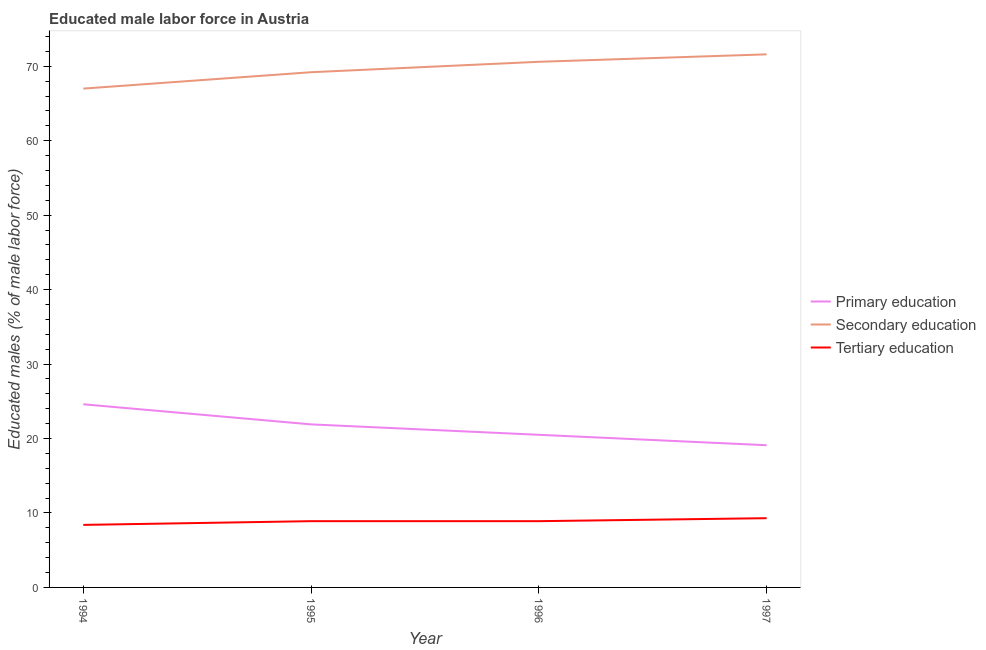How many different coloured lines are there?
Your response must be concise. 3. Does the line corresponding to percentage of male labor force who received tertiary education intersect with the line corresponding to percentage of male labor force who received primary education?
Your answer should be very brief. No. What is the percentage of male labor force who received secondary education in 1996?
Offer a very short reply. 70.6. Across all years, what is the maximum percentage of male labor force who received primary education?
Make the answer very short. 24.6. Across all years, what is the minimum percentage of male labor force who received primary education?
Your answer should be compact. 19.1. In which year was the percentage of male labor force who received secondary education maximum?
Ensure brevity in your answer.  1997. In which year was the percentage of male labor force who received primary education minimum?
Keep it short and to the point. 1997. What is the total percentage of male labor force who received secondary education in the graph?
Your answer should be very brief. 278.4. What is the difference between the percentage of male labor force who received primary education in 1994 and that in 1996?
Keep it short and to the point. 4.1. What is the difference between the percentage of male labor force who received secondary education in 1995 and the percentage of male labor force who received primary education in 1996?
Your response must be concise. 48.7. What is the average percentage of male labor force who received secondary education per year?
Ensure brevity in your answer.  69.6. In the year 1995, what is the difference between the percentage of male labor force who received primary education and percentage of male labor force who received secondary education?
Your response must be concise. -47.3. What is the ratio of the percentage of male labor force who received tertiary education in 1994 to that in 1996?
Offer a very short reply. 0.94. What is the difference between the highest and the lowest percentage of male labor force who received tertiary education?
Offer a very short reply. 0.9. Is the sum of the percentage of male labor force who received secondary education in 1994 and 1997 greater than the maximum percentage of male labor force who received primary education across all years?
Keep it short and to the point. Yes. How many lines are there?
Offer a very short reply. 3. How many years are there in the graph?
Ensure brevity in your answer.  4. What is the difference between two consecutive major ticks on the Y-axis?
Your answer should be very brief. 10. Where does the legend appear in the graph?
Offer a very short reply. Center right. How many legend labels are there?
Make the answer very short. 3. How are the legend labels stacked?
Provide a short and direct response. Vertical. What is the title of the graph?
Your answer should be compact. Educated male labor force in Austria. Does "Transport" appear as one of the legend labels in the graph?
Keep it short and to the point. No. What is the label or title of the X-axis?
Give a very brief answer. Year. What is the label or title of the Y-axis?
Provide a short and direct response. Educated males (% of male labor force). What is the Educated males (% of male labor force) of Primary education in 1994?
Your answer should be compact. 24.6. What is the Educated males (% of male labor force) of Secondary education in 1994?
Give a very brief answer. 67. What is the Educated males (% of male labor force) of Tertiary education in 1994?
Make the answer very short. 8.4. What is the Educated males (% of male labor force) in Primary education in 1995?
Your answer should be compact. 21.9. What is the Educated males (% of male labor force) of Secondary education in 1995?
Ensure brevity in your answer.  69.2. What is the Educated males (% of male labor force) of Tertiary education in 1995?
Give a very brief answer. 8.9. What is the Educated males (% of male labor force) of Primary education in 1996?
Your response must be concise. 20.5. What is the Educated males (% of male labor force) of Secondary education in 1996?
Your answer should be very brief. 70.6. What is the Educated males (% of male labor force) in Tertiary education in 1996?
Your answer should be compact. 8.9. What is the Educated males (% of male labor force) in Primary education in 1997?
Ensure brevity in your answer.  19.1. What is the Educated males (% of male labor force) of Secondary education in 1997?
Ensure brevity in your answer.  71.6. What is the Educated males (% of male labor force) in Tertiary education in 1997?
Your answer should be compact. 9.3. Across all years, what is the maximum Educated males (% of male labor force) in Primary education?
Keep it short and to the point. 24.6. Across all years, what is the maximum Educated males (% of male labor force) of Secondary education?
Keep it short and to the point. 71.6. Across all years, what is the maximum Educated males (% of male labor force) in Tertiary education?
Ensure brevity in your answer.  9.3. Across all years, what is the minimum Educated males (% of male labor force) of Primary education?
Your response must be concise. 19.1. Across all years, what is the minimum Educated males (% of male labor force) in Secondary education?
Provide a short and direct response. 67. Across all years, what is the minimum Educated males (% of male labor force) of Tertiary education?
Offer a terse response. 8.4. What is the total Educated males (% of male labor force) of Primary education in the graph?
Ensure brevity in your answer.  86.1. What is the total Educated males (% of male labor force) in Secondary education in the graph?
Offer a terse response. 278.4. What is the total Educated males (% of male labor force) in Tertiary education in the graph?
Your answer should be compact. 35.5. What is the difference between the Educated males (% of male labor force) of Secondary education in 1994 and that in 1995?
Your answer should be very brief. -2.2. What is the difference between the Educated males (% of male labor force) of Primary education in 1994 and that in 1996?
Your answer should be compact. 4.1. What is the difference between the Educated males (% of male labor force) in Secondary education in 1994 and that in 1996?
Offer a terse response. -3.6. What is the difference between the Educated males (% of male labor force) in Primary education in 1994 and that in 1997?
Your response must be concise. 5.5. What is the difference between the Educated males (% of male labor force) of Primary education in 1995 and that in 1996?
Offer a terse response. 1.4. What is the difference between the Educated males (% of male labor force) of Tertiary education in 1995 and that in 1996?
Offer a terse response. 0. What is the difference between the Educated males (% of male labor force) in Secondary education in 1995 and that in 1997?
Your answer should be very brief. -2.4. What is the difference between the Educated males (% of male labor force) of Primary education in 1996 and that in 1997?
Make the answer very short. 1.4. What is the difference between the Educated males (% of male labor force) in Secondary education in 1996 and that in 1997?
Provide a succinct answer. -1. What is the difference between the Educated males (% of male labor force) of Primary education in 1994 and the Educated males (% of male labor force) of Secondary education in 1995?
Make the answer very short. -44.6. What is the difference between the Educated males (% of male labor force) of Primary education in 1994 and the Educated males (% of male labor force) of Tertiary education in 1995?
Provide a short and direct response. 15.7. What is the difference between the Educated males (% of male labor force) of Secondary education in 1994 and the Educated males (% of male labor force) of Tertiary education in 1995?
Give a very brief answer. 58.1. What is the difference between the Educated males (% of male labor force) of Primary education in 1994 and the Educated males (% of male labor force) of Secondary education in 1996?
Your answer should be very brief. -46. What is the difference between the Educated males (% of male labor force) of Secondary education in 1994 and the Educated males (% of male labor force) of Tertiary education in 1996?
Provide a short and direct response. 58.1. What is the difference between the Educated males (% of male labor force) of Primary education in 1994 and the Educated males (% of male labor force) of Secondary education in 1997?
Your response must be concise. -47. What is the difference between the Educated males (% of male labor force) in Primary education in 1994 and the Educated males (% of male labor force) in Tertiary education in 1997?
Provide a succinct answer. 15.3. What is the difference between the Educated males (% of male labor force) in Secondary education in 1994 and the Educated males (% of male labor force) in Tertiary education in 1997?
Your answer should be compact. 57.7. What is the difference between the Educated males (% of male labor force) in Primary education in 1995 and the Educated males (% of male labor force) in Secondary education in 1996?
Your answer should be very brief. -48.7. What is the difference between the Educated males (% of male labor force) in Primary education in 1995 and the Educated males (% of male labor force) in Tertiary education in 1996?
Offer a terse response. 13. What is the difference between the Educated males (% of male labor force) of Secondary education in 1995 and the Educated males (% of male labor force) of Tertiary education in 1996?
Provide a succinct answer. 60.3. What is the difference between the Educated males (% of male labor force) of Primary education in 1995 and the Educated males (% of male labor force) of Secondary education in 1997?
Your response must be concise. -49.7. What is the difference between the Educated males (% of male labor force) in Secondary education in 1995 and the Educated males (% of male labor force) in Tertiary education in 1997?
Your answer should be very brief. 59.9. What is the difference between the Educated males (% of male labor force) of Primary education in 1996 and the Educated males (% of male labor force) of Secondary education in 1997?
Your answer should be compact. -51.1. What is the difference between the Educated males (% of male labor force) of Primary education in 1996 and the Educated males (% of male labor force) of Tertiary education in 1997?
Keep it short and to the point. 11.2. What is the difference between the Educated males (% of male labor force) in Secondary education in 1996 and the Educated males (% of male labor force) in Tertiary education in 1997?
Offer a very short reply. 61.3. What is the average Educated males (% of male labor force) in Primary education per year?
Make the answer very short. 21.52. What is the average Educated males (% of male labor force) of Secondary education per year?
Offer a terse response. 69.6. What is the average Educated males (% of male labor force) of Tertiary education per year?
Offer a very short reply. 8.88. In the year 1994, what is the difference between the Educated males (% of male labor force) of Primary education and Educated males (% of male labor force) of Secondary education?
Make the answer very short. -42.4. In the year 1994, what is the difference between the Educated males (% of male labor force) of Secondary education and Educated males (% of male labor force) of Tertiary education?
Provide a succinct answer. 58.6. In the year 1995, what is the difference between the Educated males (% of male labor force) in Primary education and Educated males (% of male labor force) in Secondary education?
Make the answer very short. -47.3. In the year 1995, what is the difference between the Educated males (% of male labor force) in Secondary education and Educated males (% of male labor force) in Tertiary education?
Ensure brevity in your answer.  60.3. In the year 1996, what is the difference between the Educated males (% of male labor force) in Primary education and Educated males (% of male labor force) in Secondary education?
Provide a short and direct response. -50.1. In the year 1996, what is the difference between the Educated males (% of male labor force) of Secondary education and Educated males (% of male labor force) of Tertiary education?
Keep it short and to the point. 61.7. In the year 1997, what is the difference between the Educated males (% of male labor force) in Primary education and Educated males (% of male labor force) in Secondary education?
Provide a short and direct response. -52.5. In the year 1997, what is the difference between the Educated males (% of male labor force) of Primary education and Educated males (% of male labor force) of Tertiary education?
Keep it short and to the point. 9.8. In the year 1997, what is the difference between the Educated males (% of male labor force) of Secondary education and Educated males (% of male labor force) of Tertiary education?
Offer a very short reply. 62.3. What is the ratio of the Educated males (% of male labor force) in Primary education in 1994 to that in 1995?
Offer a terse response. 1.12. What is the ratio of the Educated males (% of male labor force) of Secondary education in 1994 to that in 1995?
Your answer should be very brief. 0.97. What is the ratio of the Educated males (% of male labor force) of Tertiary education in 1994 to that in 1995?
Make the answer very short. 0.94. What is the ratio of the Educated males (% of male labor force) of Primary education in 1994 to that in 1996?
Your answer should be compact. 1.2. What is the ratio of the Educated males (% of male labor force) of Secondary education in 1994 to that in 1996?
Ensure brevity in your answer.  0.95. What is the ratio of the Educated males (% of male labor force) in Tertiary education in 1994 to that in 1996?
Your response must be concise. 0.94. What is the ratio of the Educated males (% of male labor force) in Primary education in 1994 to that in 1997?
Provide a short and direct response. 1.29. What is the ratio of the Educated males (% of male labor force) in Secondary education in 1994 to that in 1997?
Offer a very short reply. 0.94. What is the ratio of the Educated males (% of male labor force) in Tertiary education in 1994 to that in 1997?
Provide a short and direct response. 0.9. What is the ratio of the Educated males (% of male labor force) of Primary education in 1995 to that in 1996?
Your answer should be very brief. 1.07. What is the ratio of the Educated males (% of male labor force) in Secondary education in 1995 to that in 1996?
Make the answer very short. 0.98. What is the ratio of the Educated males (% of male labor force) of Primary education in 1995 to that in 1997?
Give a very brief answer. 1.15. What is the ratio of the Educated males (% of male labor force) in Secondary education in 1995 to that in 1997?
Give a very brief answer. 0.97. What is the ratio of the Educated males (% of male labor force) of Primary education in 1996 to that in 1997?
Ensure brevity in your answer.  1.07. What is the ratio of the Educated males (% of male labor force) in Secondary education in 1996 to that in 1997?
Your response must be concise. 0.99. What is the difference between the highest and the second highest Educated males (% of male labor force) of Primary education?
Your response must be concise. 2.7. What is the difference between the highest and the second highest Educated males (% of male labor force) of Secondary education?
Give a very brief answer. 1. 